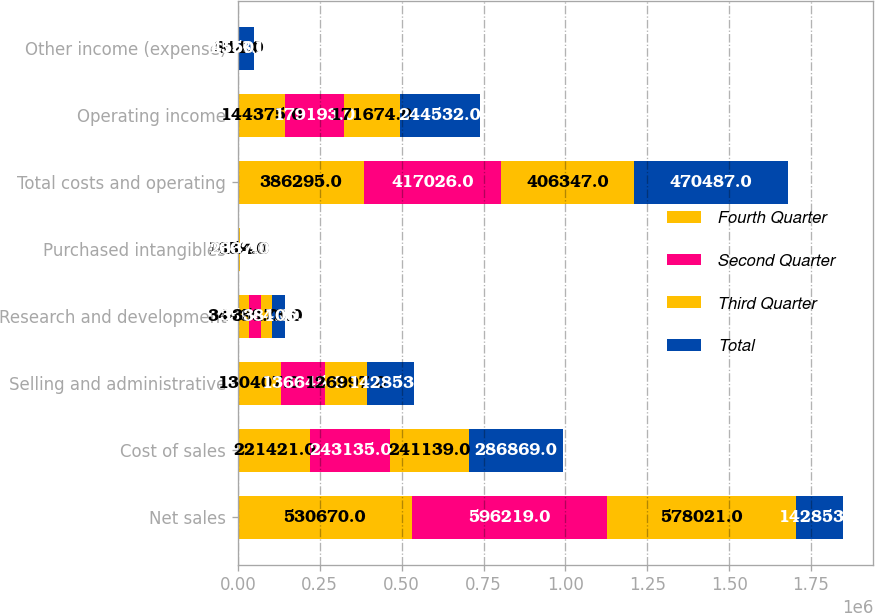Convert chart to OTSL. <chart><loc_0><loc_0><loc_500><loc_500><stacked_bar_chart><ecel><fcel>Net sales<fcel>Cost of sales<fcel>Selling and administrative<fcel>Research and development<fcel>Purchased intangibles<fcel>Total costs and operating<fcel>Operating income<fcel>Other income (expense)<nl><fcel>Fourth Quarter<fcel>530670<fcel>221421<fcel>130407<fcel>34480<fcel>1659<fcel>386295<fcel>144375<fcel>346<nl><fcel>Second Quarter<fcel>596219<fcel>243135<fcel>136645<fcel>35644<fcel>1602<fcel>417026<fcel>179193<fcel>1828<nl><fcel>Third Quarter<fcel>578021<fcel>241139<fcel>126997<fcel>35173<fcel>2114<fcel>406347<fcel>171674<fcel>811<nl><fcel>Total<fcel>142853<fcel>286869<fcel>142853<fcel>38106<fcel>2337<fcel>470487<fcel>244532<fcel>45501<nl></chart> 